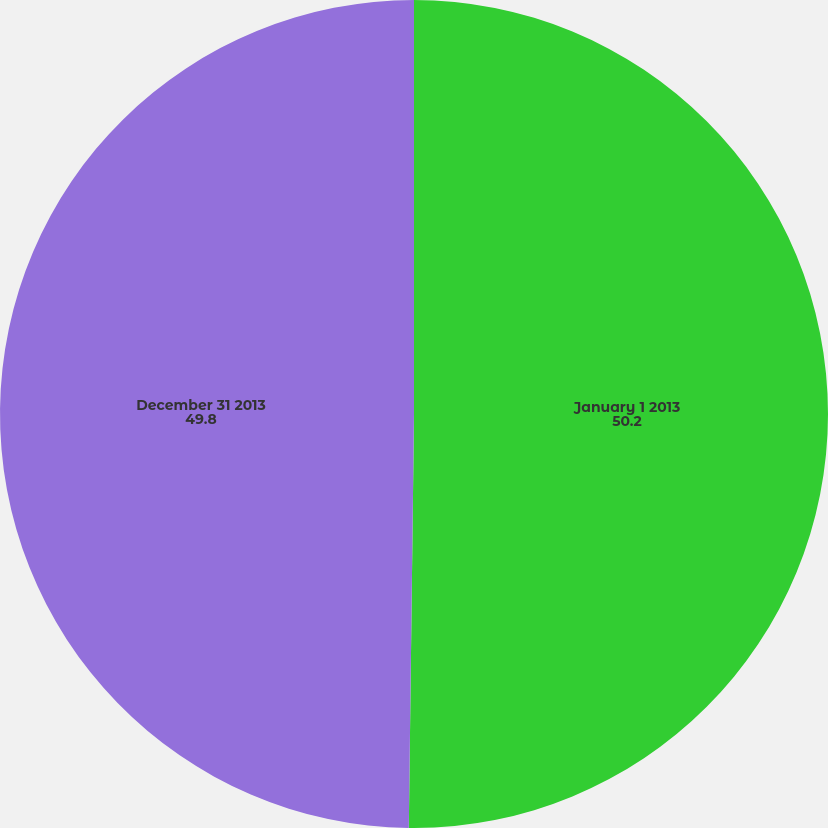Convert chart. <chart><loc_0><loc_0><loc_500><loc_500><pie_chart><fcel>January 1 2013<fcel>December 31 2013<nl><fcel>50.2%<fcel>49.8%<nl></chart> 